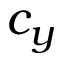Convert formula to latex. <formula><loc_0><loc_0><loc_500><loc_500>c _ { y }</formula> 